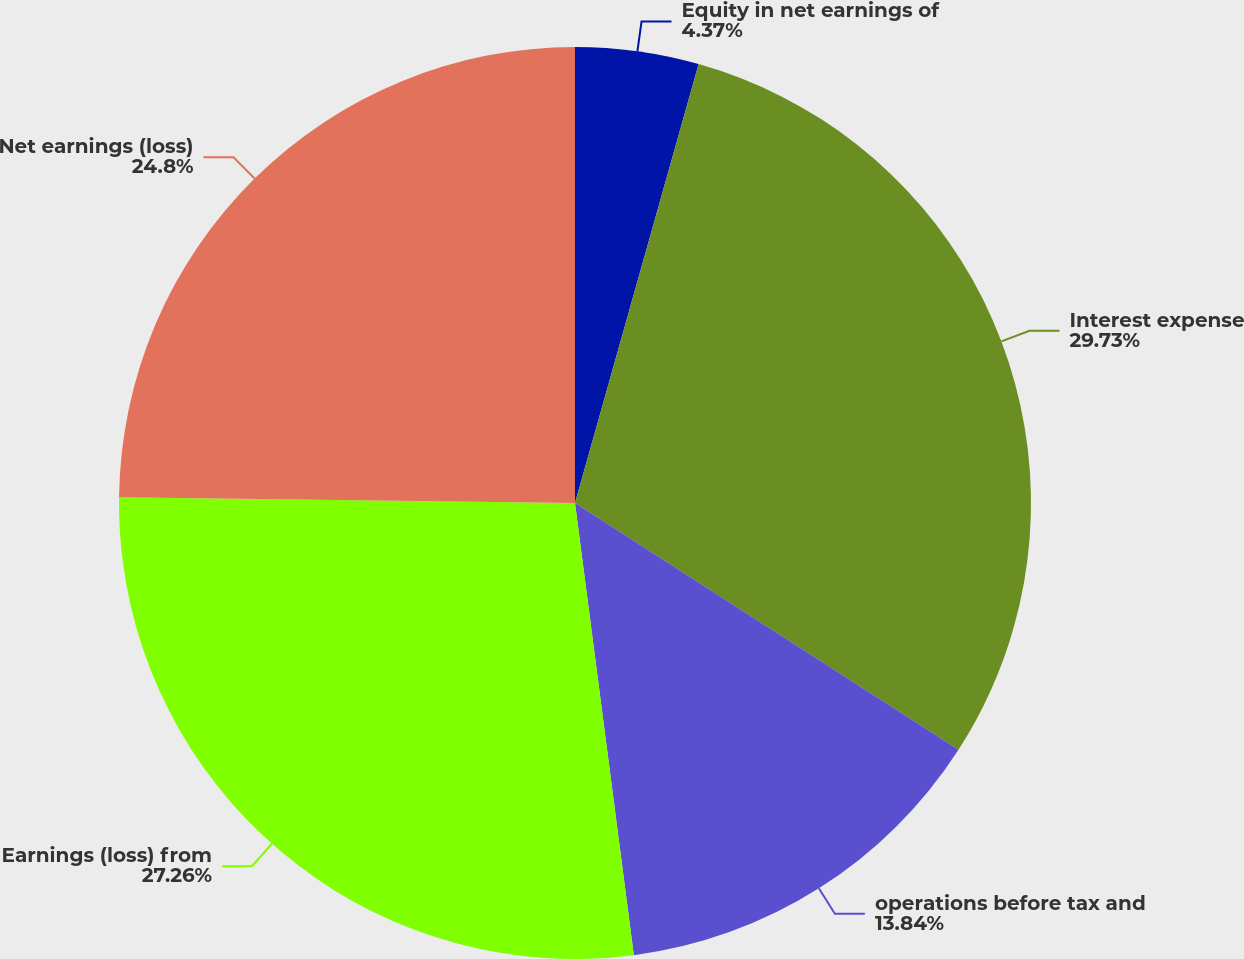Convert chart to OTSL. <chart><loc_0><loc_0><loc_500><loc_500><pie_chart><fcel>Equity in net earnings of<fcel>Interest expense<fcel>operations before tax and<fcel>Earnings (loss) from<fcel>Net earnings (loss)<nl><fcel>4.37%<fcel>29.73%<fcel>13.84%<fcel>27.26%<fcel>24.8%<nl></chart> 